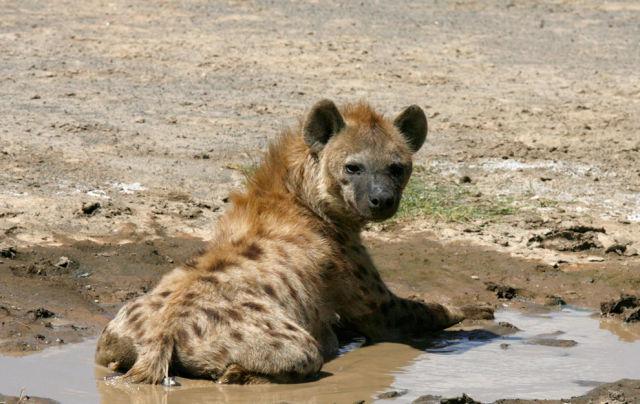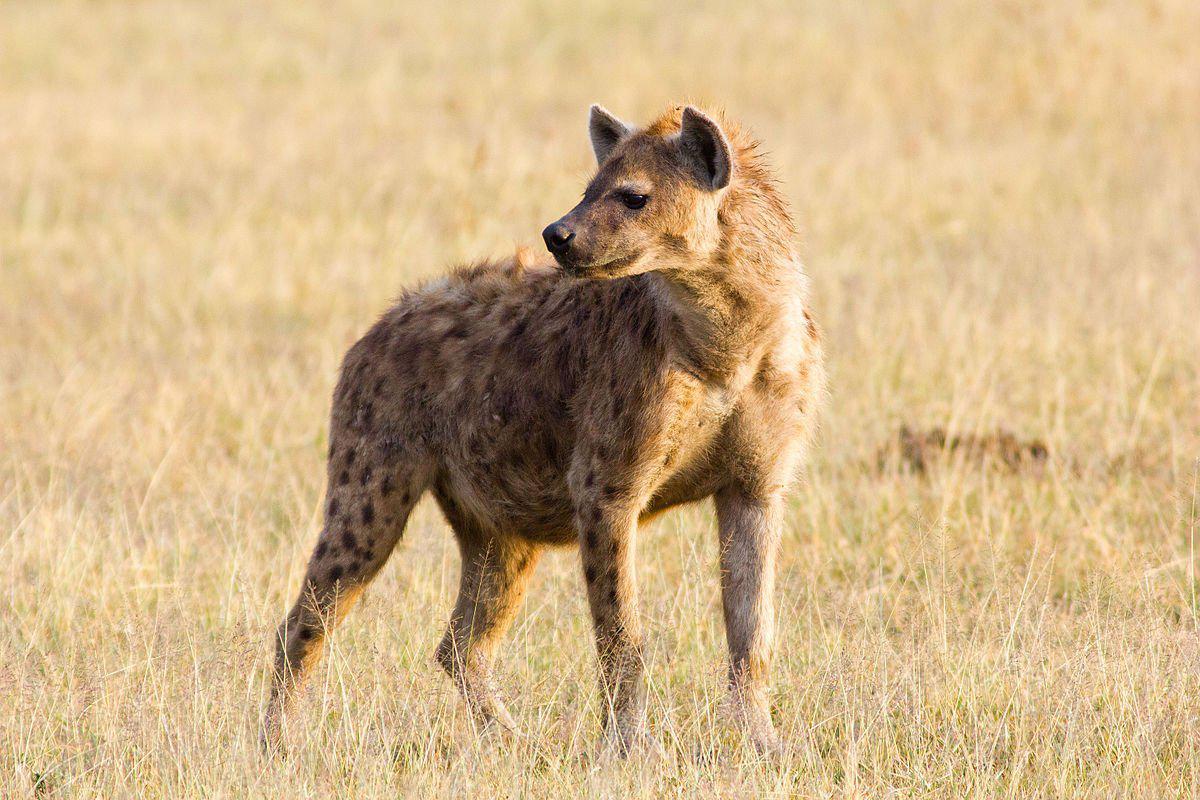The first image is the image on the left, the second image is the image on the right. Considering the images on both sides, is "One image shows a single hyena moving forward and slightly to the left, and the other image includes a hyena with a wide-open fang-baring mouth and its body facing forward." valid? Answer yes or no. No. The first image is the image on the left, the second image is the image on the right. Examine the images to the left and right. Is the description "There are two hyenas." accurate? Answer yes or no. Yes. 